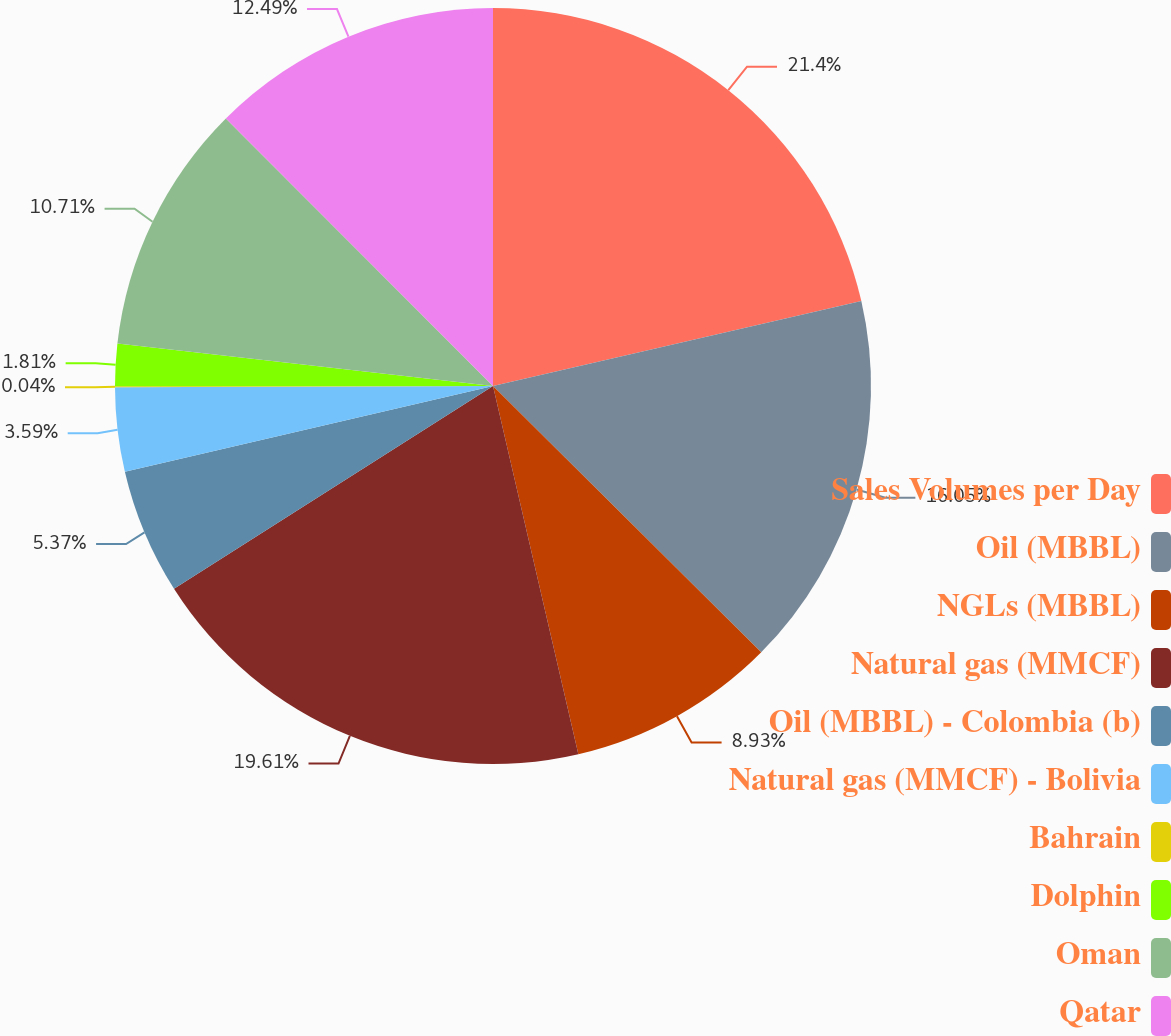<chart> <loc_0><loc_0><loc_500><loc_500><pie_chart><fcel>Sales Volumes per Day<fcel>Oil (MBBL)<fcel>NGLs (MBBL)<fcel>Natural gas (MMCF)<fcel>Oil (MBBL) - Colombia (b)<fcel>Natural gas (MMCF) - Bolivia<fcel>Bahrain<fcel>Dolphin<fcel>Oman<fcel>Qatar<nl><fcel>21.39%<fcel>16.05%<fcel>8.93%<fcel>19.61%<fcel>5.37%<fcel>3.59%<fcel>0.04%<fcel>1.81%<fcel>10.71%<fcel>12.49%<nl></chart> 